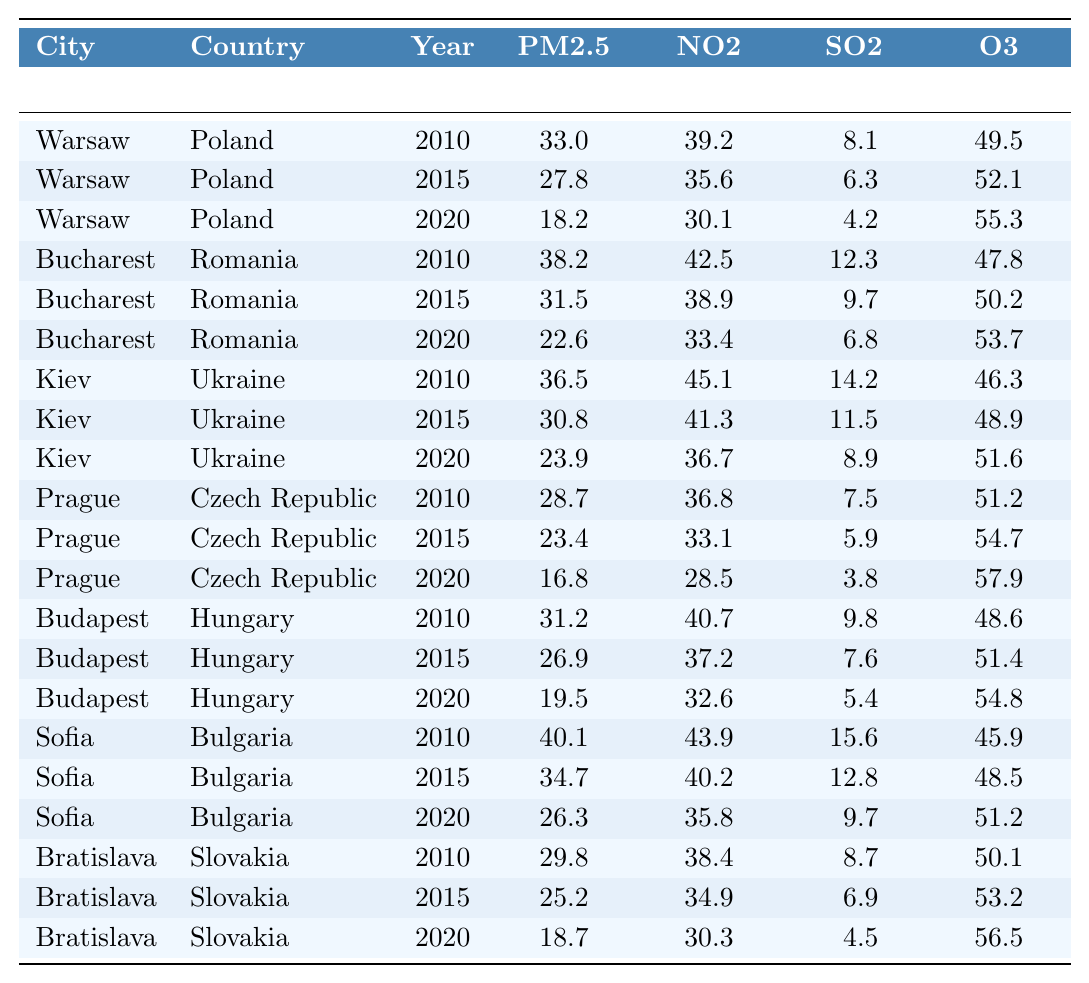What was the PM2.5 level in Warsaw in 2020? In the table, I can locate Warsaw under the year 2020, where the PM2.5 level is recorded as 18.2 µg/m³.
Answer: 18.2 µg/m³ Which city had the highest NO2 level in 2010? By examining the values for NO2 in 2010, Kiev has the highest level recorded at 45.1 µg/m³ compared to the other cities.
Answer: Kiev What is the difference in SO2 levels between Bucharest in 2020 and Warsaw in 2020? For Bucharest in 2020, the SO2 level is 6.8 µg/m³; for Warsaw in 2020, it is 4.2 µg/m³. The difference is calculated as 6.8 - 4.2 = 2.6 µg/m³.
Answer: 2.6 µg/m³ What was the average PM2.5 level across all cities in 2015? To find the average PM2.5 for 2015, I sum the PM2.5 levels: (27.8 + 31.5 + 30.8 + 23.4 + 26.9 + 34.7 + 25.2) = 200.3. Then, divide by the number of cities, which is 7: 200.3 / 7 = approximately 28.6 µg/m³.
Answer: 28.6 µg/m³ Was the O3 level in Budapest higher or lower in 2020 compared to 2015? In the table, for Budapest, the O3 level was 51.4 µg/m³ in 2015 and increased to 54.8 µg/m³ in 2020, indicating it was higher.
Answer: Higher Which city experienced the largest reduction in PM2.5 levels from 2010 to 2020? To evaluate reductions, I compare the PM2.5 levels: Warsaw decreased from 33.0 to 18.2 (14.8), Bucharest from 38.2 to 22.6 (15.6), Kiev from 36.5 to 23.9 (12.6), Prague from 28.7 to 16.8 (11.9), Budapest from 31.2 to 19.5 (11.7), Sofia from 40.1 to 26.3 (13.8), and Bratislava from 29.8 to 18.7 (11.1). Bucharest with a decrease of 15.6 shows the largest reduction.
Answer: Bucharest How much did the NO2 levels in Sofia decline from 2010 to 2020? The NO2 level in Sofia in 2010 was 43.9 µg/m³, and in 2020 it was 35.8 µg/m³. The decline is calculated as 43.9 - 35.8 = 8.1 µg/m³.
Answer: 8.1 µg/m³ In which year did Prague record the lowest SO2 level, and what was the value? Reviewing the SO2 levels for Prague shows it was 7.5 µg/m³ in 2010, 5.9 µg/m³ in 2015, and 3.8 µg/m³ in 2020. Thus, the lowest was in 2020 at 3.8 µg/m³.
Answer: 2020, 3.8 µg/m³ Which city had the highest O3 level in 2015? Checking the O3 levels for 2015, I find that Prague shows the highest level at 54.7 µg/m³ compared to others.
Answer: Prague How did the average NO2 level from 2010 to 2020 change across all cities? Summing each year's NO2 levels: 2010 (39.2 + 42.5 + 45.1 + 36.8 + 40.7 + 43.9 + 38.4) = 286.6; 2015 (35.6 + 38.9 + 41.3 + 33.1 + 37.2 + 40.2 + 34.9) = 261.2; 2020 (30.1 + 33.4 + 36.7 + 28.5 + 32.6 + 35.8 + 30.3) = 226.4. The average for each year: 286.6/7 ≈ 40.9, 261.2/7 ≈ 37.3, 226.4/7 ≈ 32.4, indicating a decline each year.
Answer: Decline 